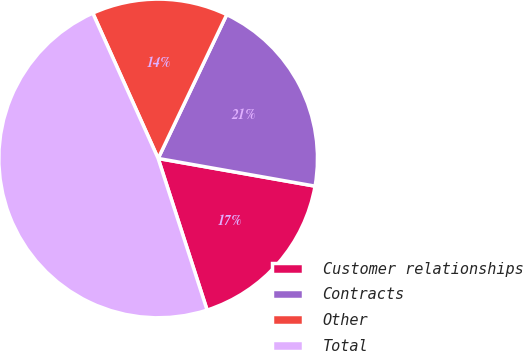<chart> <loc_0><loc_0><loc_500><loc_500><pie_chart><fcel>Customer relationships<fcel>Contracts<fcel>Other<fcel>Total<nl><fcel>17.25%<fcel>20.7%<fcel>13.81%<fcel>48.24%<nl></chart> 